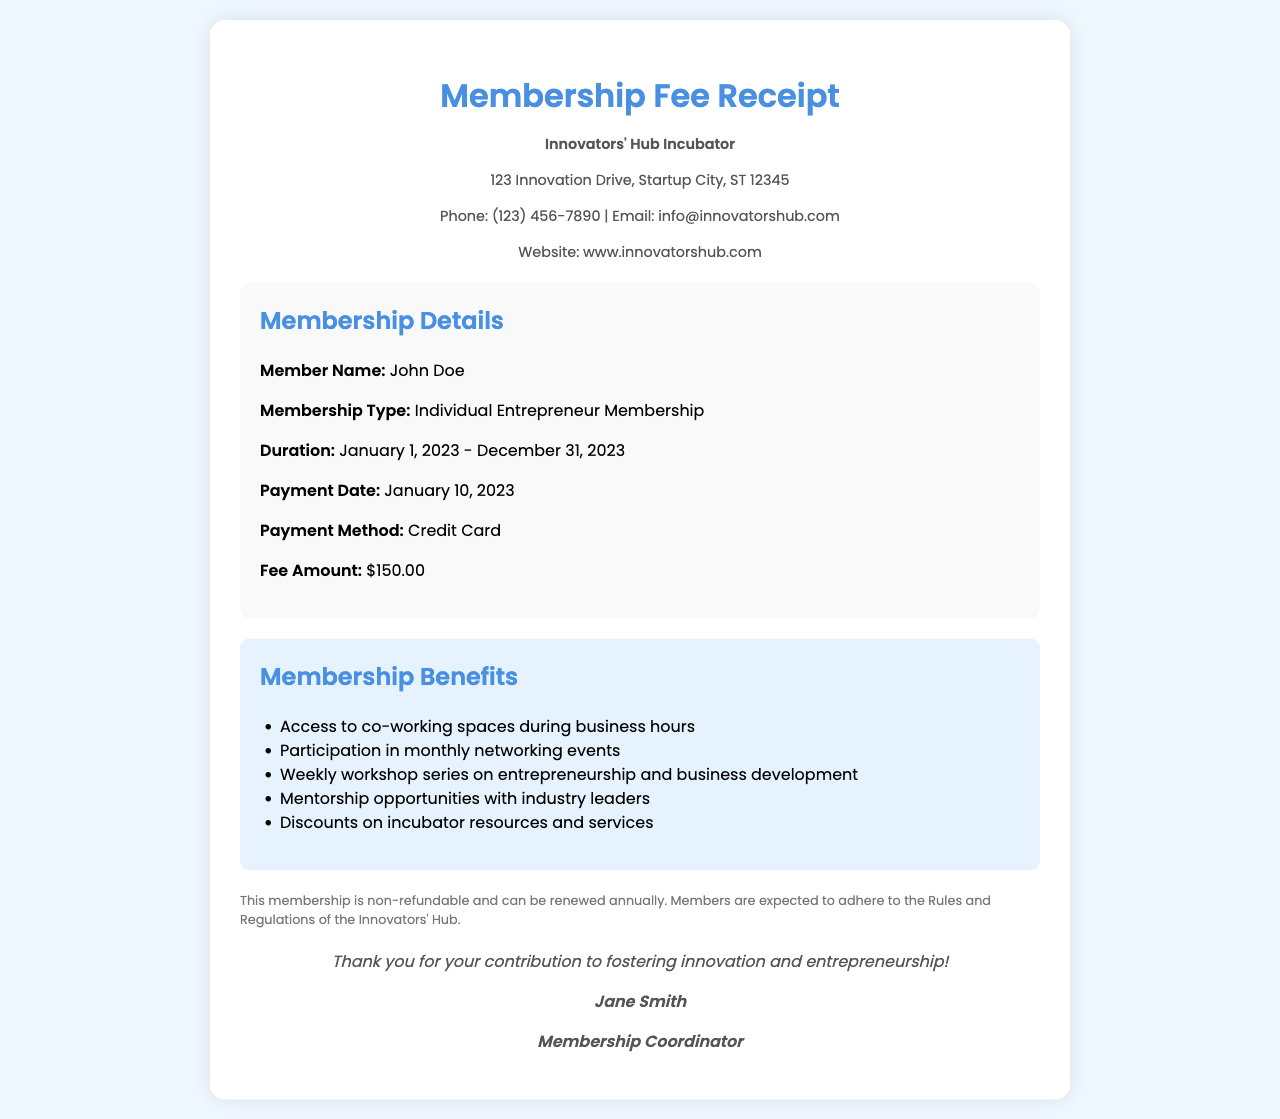What is the name of the member? The document states the member's name is John Doe.
Answer: John Doe What is the membership type? The membership type listed is "Individual Entrepreneur Membership."
Answer: Individual Entrepreneur Membership What is the fee amount? The fee amount mentioned in the document is $150.00.
Answer: $150.00 What is the payment date? The payment date provided in the document is January 10, 2023.
Answer: January 10, 2023 What benefits include access to co-working spaces? The document lists "Access to co-working spaces during business hours" as one of the membership benefits.
Answer: Access to co-working spaces during business hours How long is the membership duration? The duration of the membership is from January 1, 2023, to December 31, 2023.
Answer: January 1, 2023 - December 31, 2023 Who is the membership coordinator? The coordinator's name, as mentioned, is Jane Smith.
Answer: Jane Smith What is the organization's phone number? The organization's phone number listed is (123) 456-7890.
Answer: (123) 456-7890 Is the membership refundable? The document states that the membership is non-refundable.
Answer: Non-refundable 